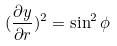Convert formula to latex. <formula><loc_0><loc_0><loc_500><loc_500>( \frac { \partial y } { \partial r } ) ^ { 2 } = \sin ^ { 2 } \phi</formula> 